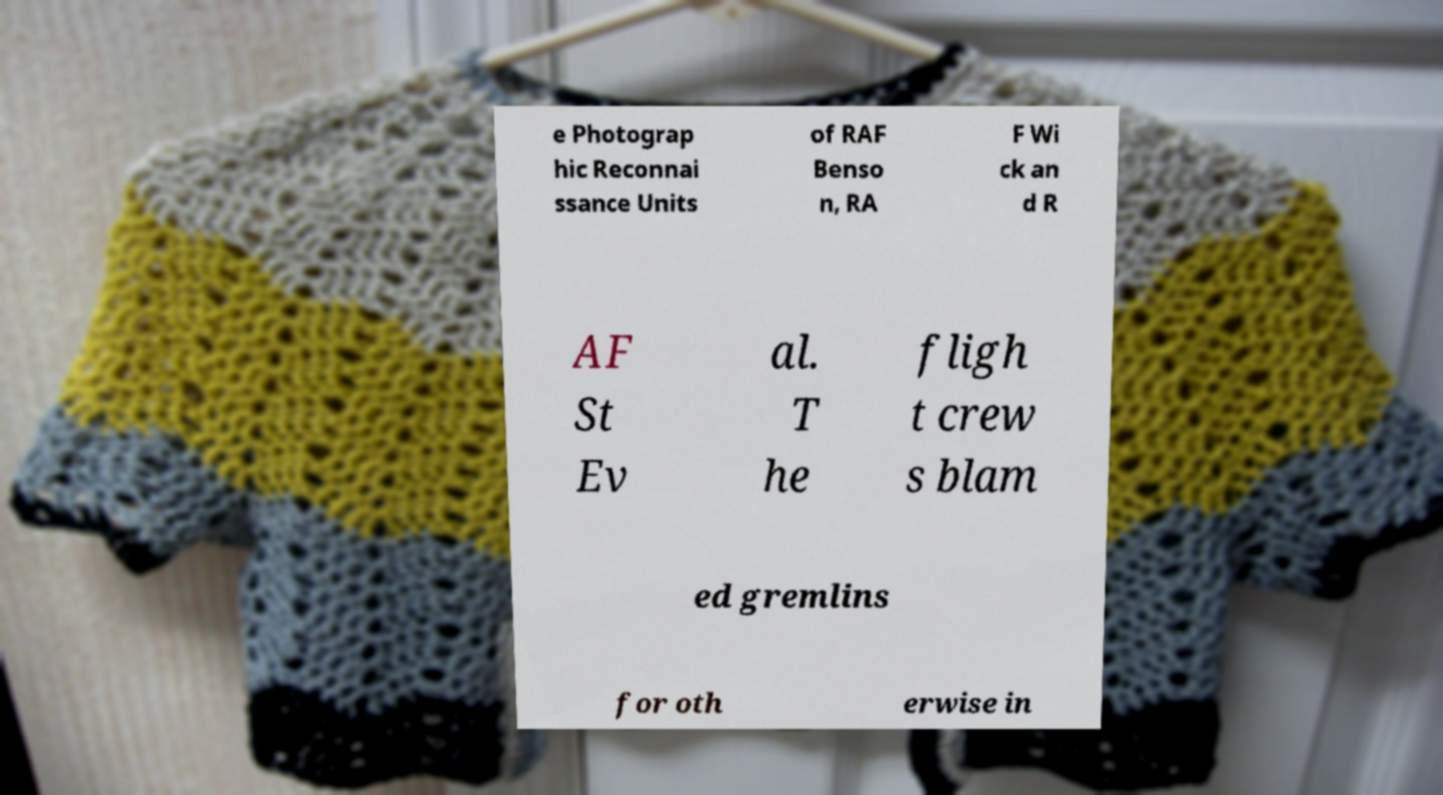For documentation purposes, I need the text within this image transcribed. Could you provide that? e Photograp hic Reconnai ssance Units of RAF Benso n, RA F Wi ck an d R AF St Ev al. T he fligh t crew s blam ed gremlins for oth erwise in 